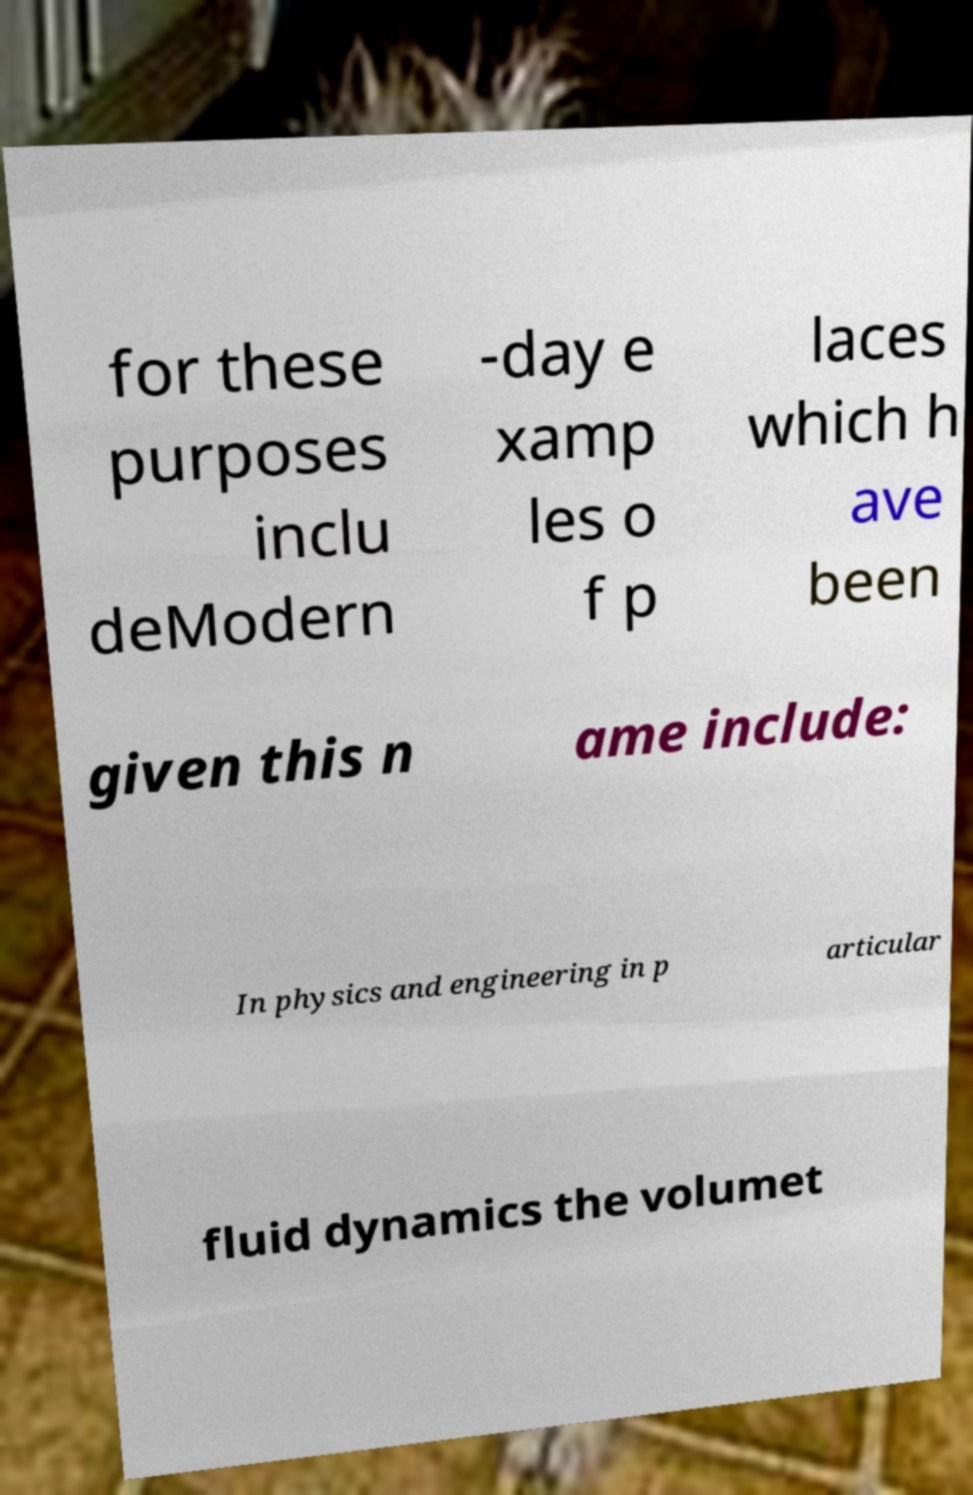I need the written content from this picture converted into text. Can you do that? for these purposes inclu deModern -day e xamp les o f p laces which h ave been given this n ame include: In physics and engineering in p articular fluid dynamics the volumet 